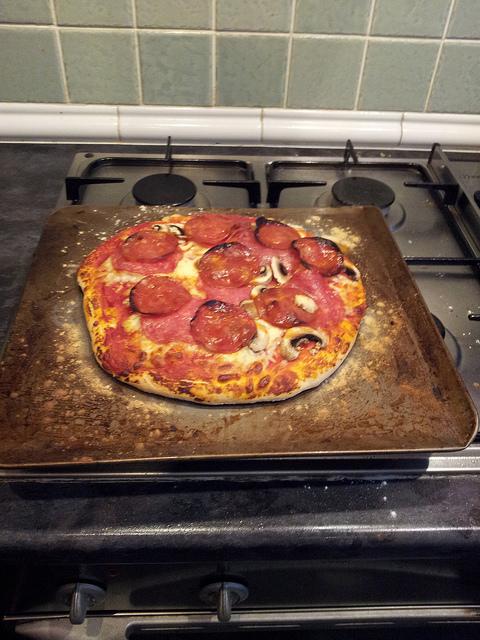Why is there black on the pepperoni?
Give a very brief answer. Burnt. How many pizzas are on the stove?
Keep it brief. 1. Is any part of the pizza burnt?
Write a very short answer. Yes. 